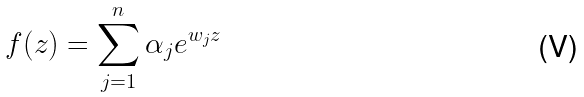Convert formula to latex. <formula><loc_0><loc_0><loc_500><loc_500>f ( z ) = \sum _ { j = 1 } ^ { n } \alpha _ { j } e ^ { w _ { j } z }</formula> 